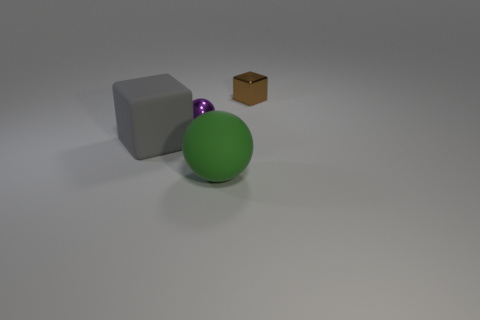Subtract 2 cubes. How many cubes are left? 0 Add 3 rubber spheres. How many rubber spheres exist? 4 Add 1 large green things. How many objects exist? 5 Subtract 0 brown cylinders. How many objects are left? 4 Subtract all purple balls. Subtract all gray cubes. How many balls are left? 1 Subtract all yellow spheres. How many gray cubes are left? 1 Subtract all tiny brown balls. Subtract all large matte balls. How many objects are left? 3 Add 4 matte spheres. How many matte spheres are left? 5 